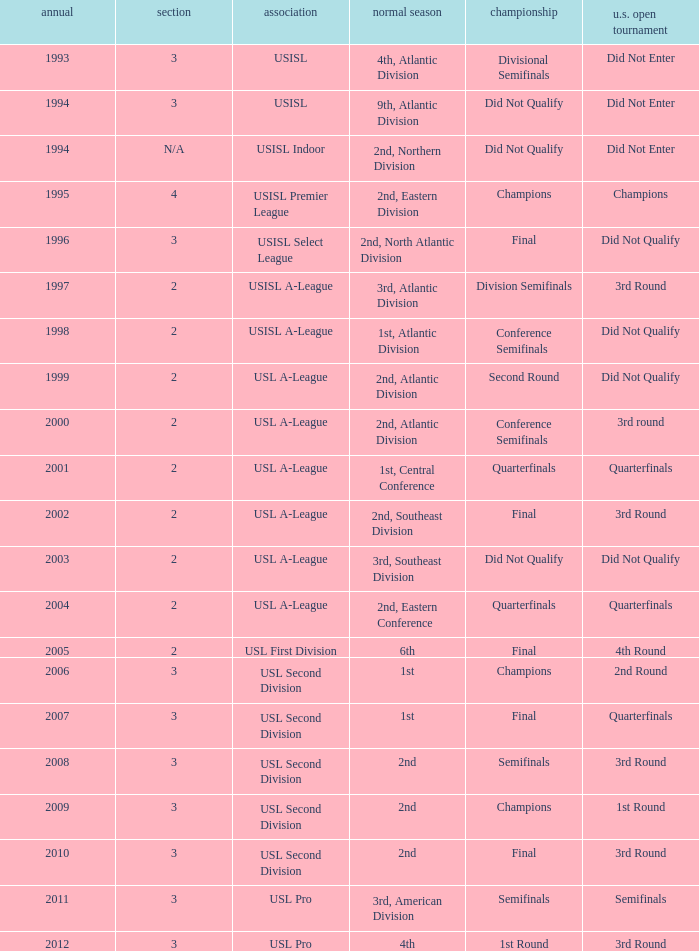What are all the playoffs for u.s. open cup in 1st round Champions. 